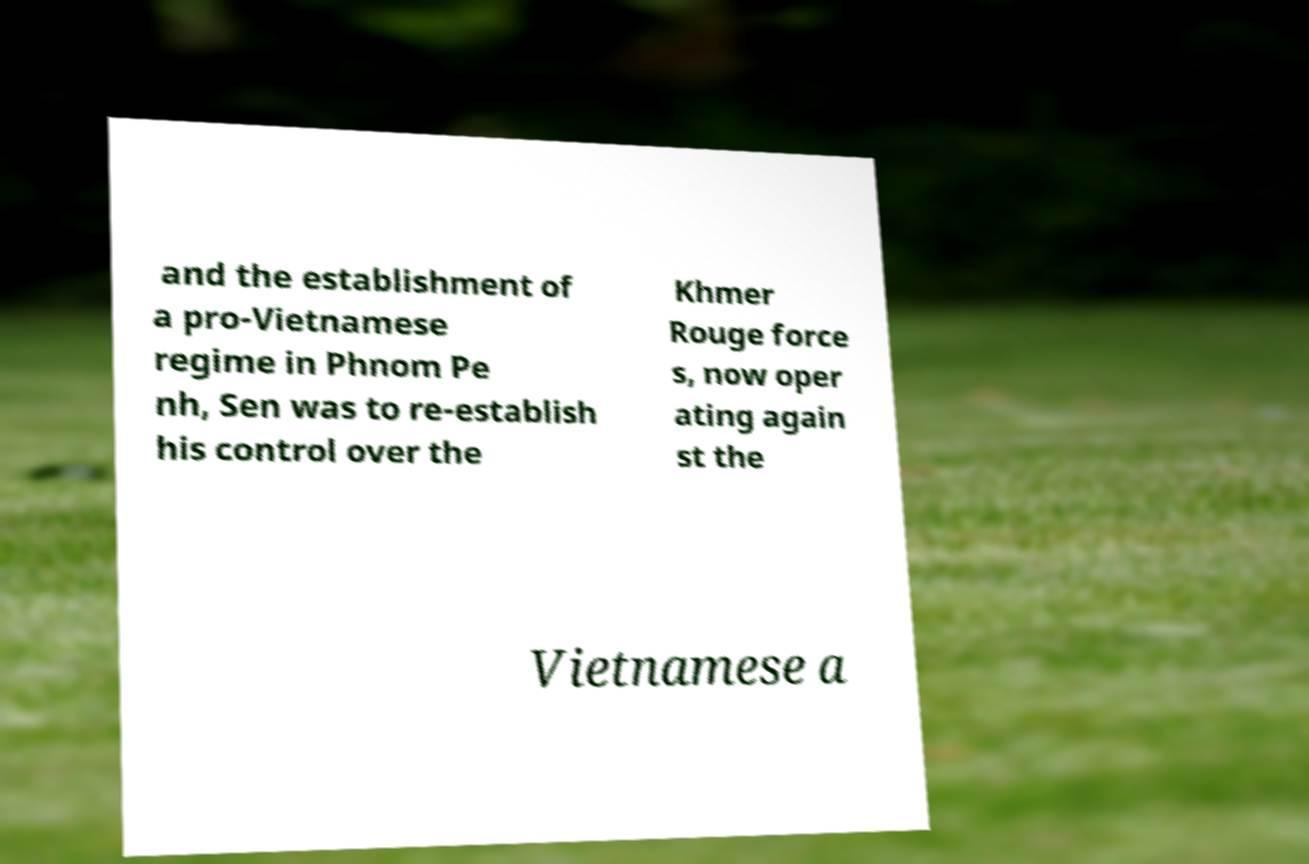Please identify and transcribe the text found in this image. and the establishment of a pro-Vietnamese regime in Phnom Pe nh, Sen was to re-establish his control over the Khmer Rouge force s, now oper ating again st the Vietnamese a 